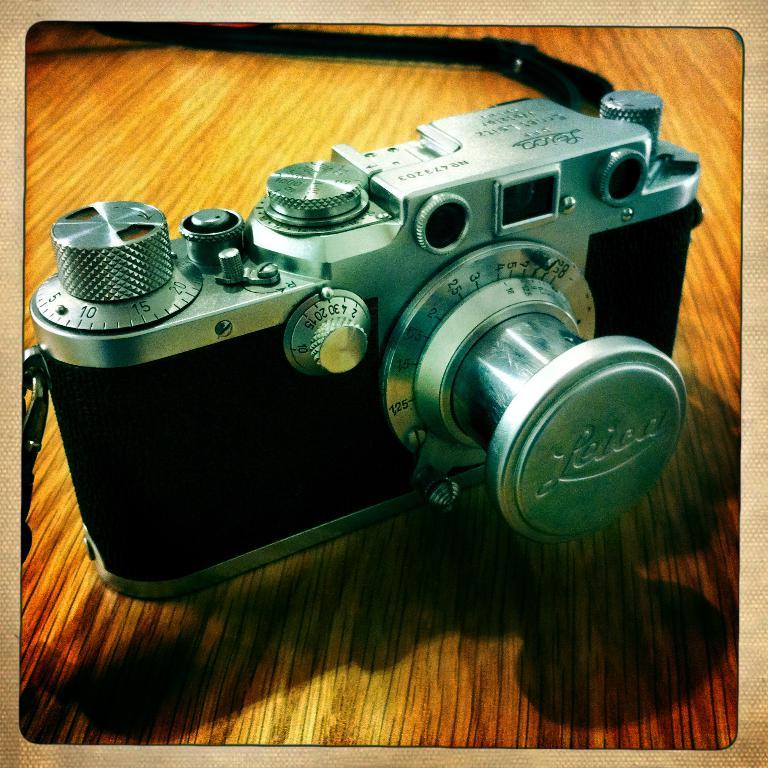What is the main object in the image? There is a camera in the image. Where is the camera placed? The camera is on a wooden surface. What type of tank is visible in the image? There is no tank present in the image; it only features a camera on a wooden surface. What letter is being used to measure the camera's dimensions in the image? There is no letter or measurement tool present in the image; it only features a camera on a wooden surface. 